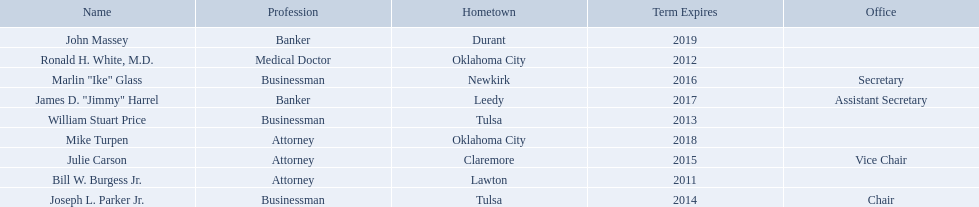What businessmen were born in tulsa? William Stuart Price, Joseph L. Parker Jr. Which man, other than price, was born in tulsa? Joseph L. Parker Jr. Parse the full table in json format. {'header': ['Name', 'Profession', 'Hometown', 'Term Expires', 'Office'], 'rows': [['John Massey', 'Banker', 'Durant', '2019', ''], ['Ronald H. White, M.D.', 'Medical Doctor', 'Oklahoma City', '2012', ''], ['Marlin "Ike" Glass', 'Businessman', 'Newkirk', '2016', 'Secretary'], ['James D. "Jimmy" Harrel', 'Banker', 'Leedy', '2017', 'Assistant Secretary'], ['William Stuart Price', 'Businessman', 'Tulsa', '2013', ''], ['Mike Turpen', 'Attorney', 'Oklahoma City', '2018', ''], ['Julie Carson', 'Attorney', 'Claremore', '2015', 'Vice Chair'], ['Bill W. Burgess Jr.', 'Attorney', 'Lawton', '2011', ''], ['Joseph L. Parker Jr.', 'Businessman', 'Tulsa', '2014', 'Chair']]} What are all of the names? Bill W. Burgess Jr., Ronald H. White, M.D., William Stuart Price, Joseph L. Parker Jr., Julie Carson, Marlin "Ike" Glass, James D. "Jimmy" Harrel, Mike Turpen, John Massey. Where is each member from? Lawton, Oklahoma City, Tulsa, Tulsa, Claremore, Newkirk, Leedy, Oklahoma City, Durant. Along with joseph l. parker jr., which other member is from tulsa? William Stuart Price. 